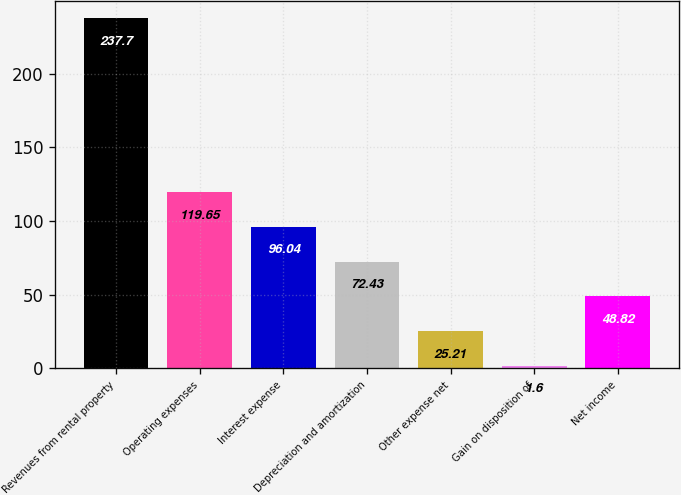Convert chart. <chart><loc_0><loc_0><loc_500><loc_500><bar_chart><fcel>Revenues from rental property<fcel>Operating expenses<fcel>Interest expense<fcel>Depreciation and amortization<fcel>Other expense net<fcel>Gain on disposition of<fcel>Net income<nl><fcel>237.7<fcel>119.65<fcel>96.04<fcel>72.43<fcel>25.21<fcel>1.6<fcel>48.82<nl></chart> 